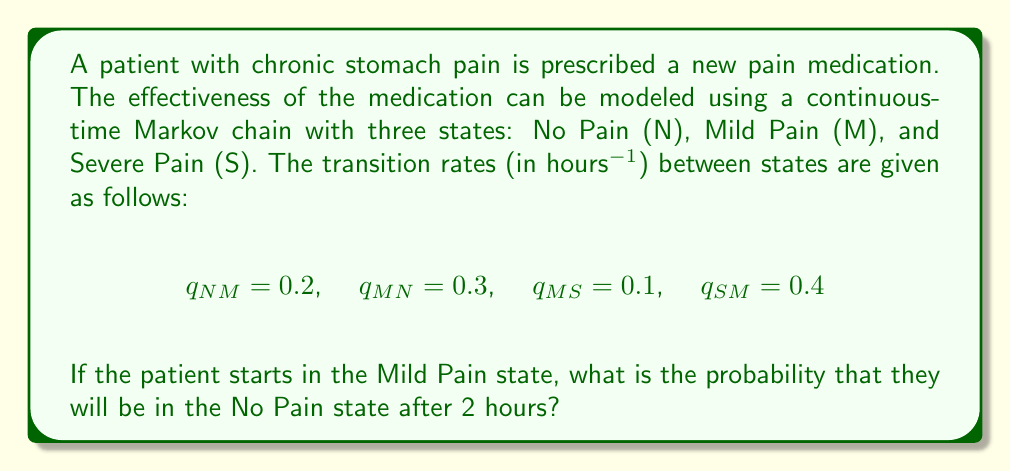Could you help me with this problem? To solve this problem, we need to use the continuous-time Markov chain (CTMC) model and calculate the transition probabilities over time. Let's approach this step-by-step:

1) First, we need to set up the infinitesimal generator matrix Q:

   $$Q = \begin{bmatrix}
   -0.2 & 0.2 & 0 \\
   0.3 & -0.4 & 0.1 \\
   0 & 0.4 & -0.4
   \end{bmatrix}$$

2) The transition probability matrix P(t) is given by the matrix exponential:

   $$P(t) = e^{Qt}$$

3) To calculate this, we can use the spectral decomposition method:

   $$P(t) = Ve^{\Lambda t}V^{-1}$$

   where V is the matrix of eigenvectors and Λ is the diagonal matrix of eigenvalues of Q.

4) Calculating the eigenvalues and eigenvectors (this step is typically done using software):

   Eigenvalues: $\lambda_1 = 0$, $\lambda_2 \approx -0.2789$, $\lambda_3 \approx -0.7211$

   Eigenvectors:
   $$V \approx \begin{bmatrix}
   0.5455 & -0.7071 & 0.4472 \\
   0.5455 & 0.7071 & -0.4472 \\
   0.6364 & 0 & 0.7746
   \end{bmatrix}$$

5) Now we can calculate P(t) for t = 2:

   $$P(2) \approx \begin{bmatrix}
   0.4122 & 0.3957 & 0.1921 \\
   0.3957 & 0.4287 & 0.1756 \\
   0.3842 & 0.3512 & 0.2646
   \end{bmatrix}$$

6) The probability of being in the No Pain state (N) after 2 hours, starting from the Mild Pain state (M), is given by the element in the first column, second row of P(2):

   $$P_{MN}(2) \approx 0.3957$$
Answer: 0.3957 